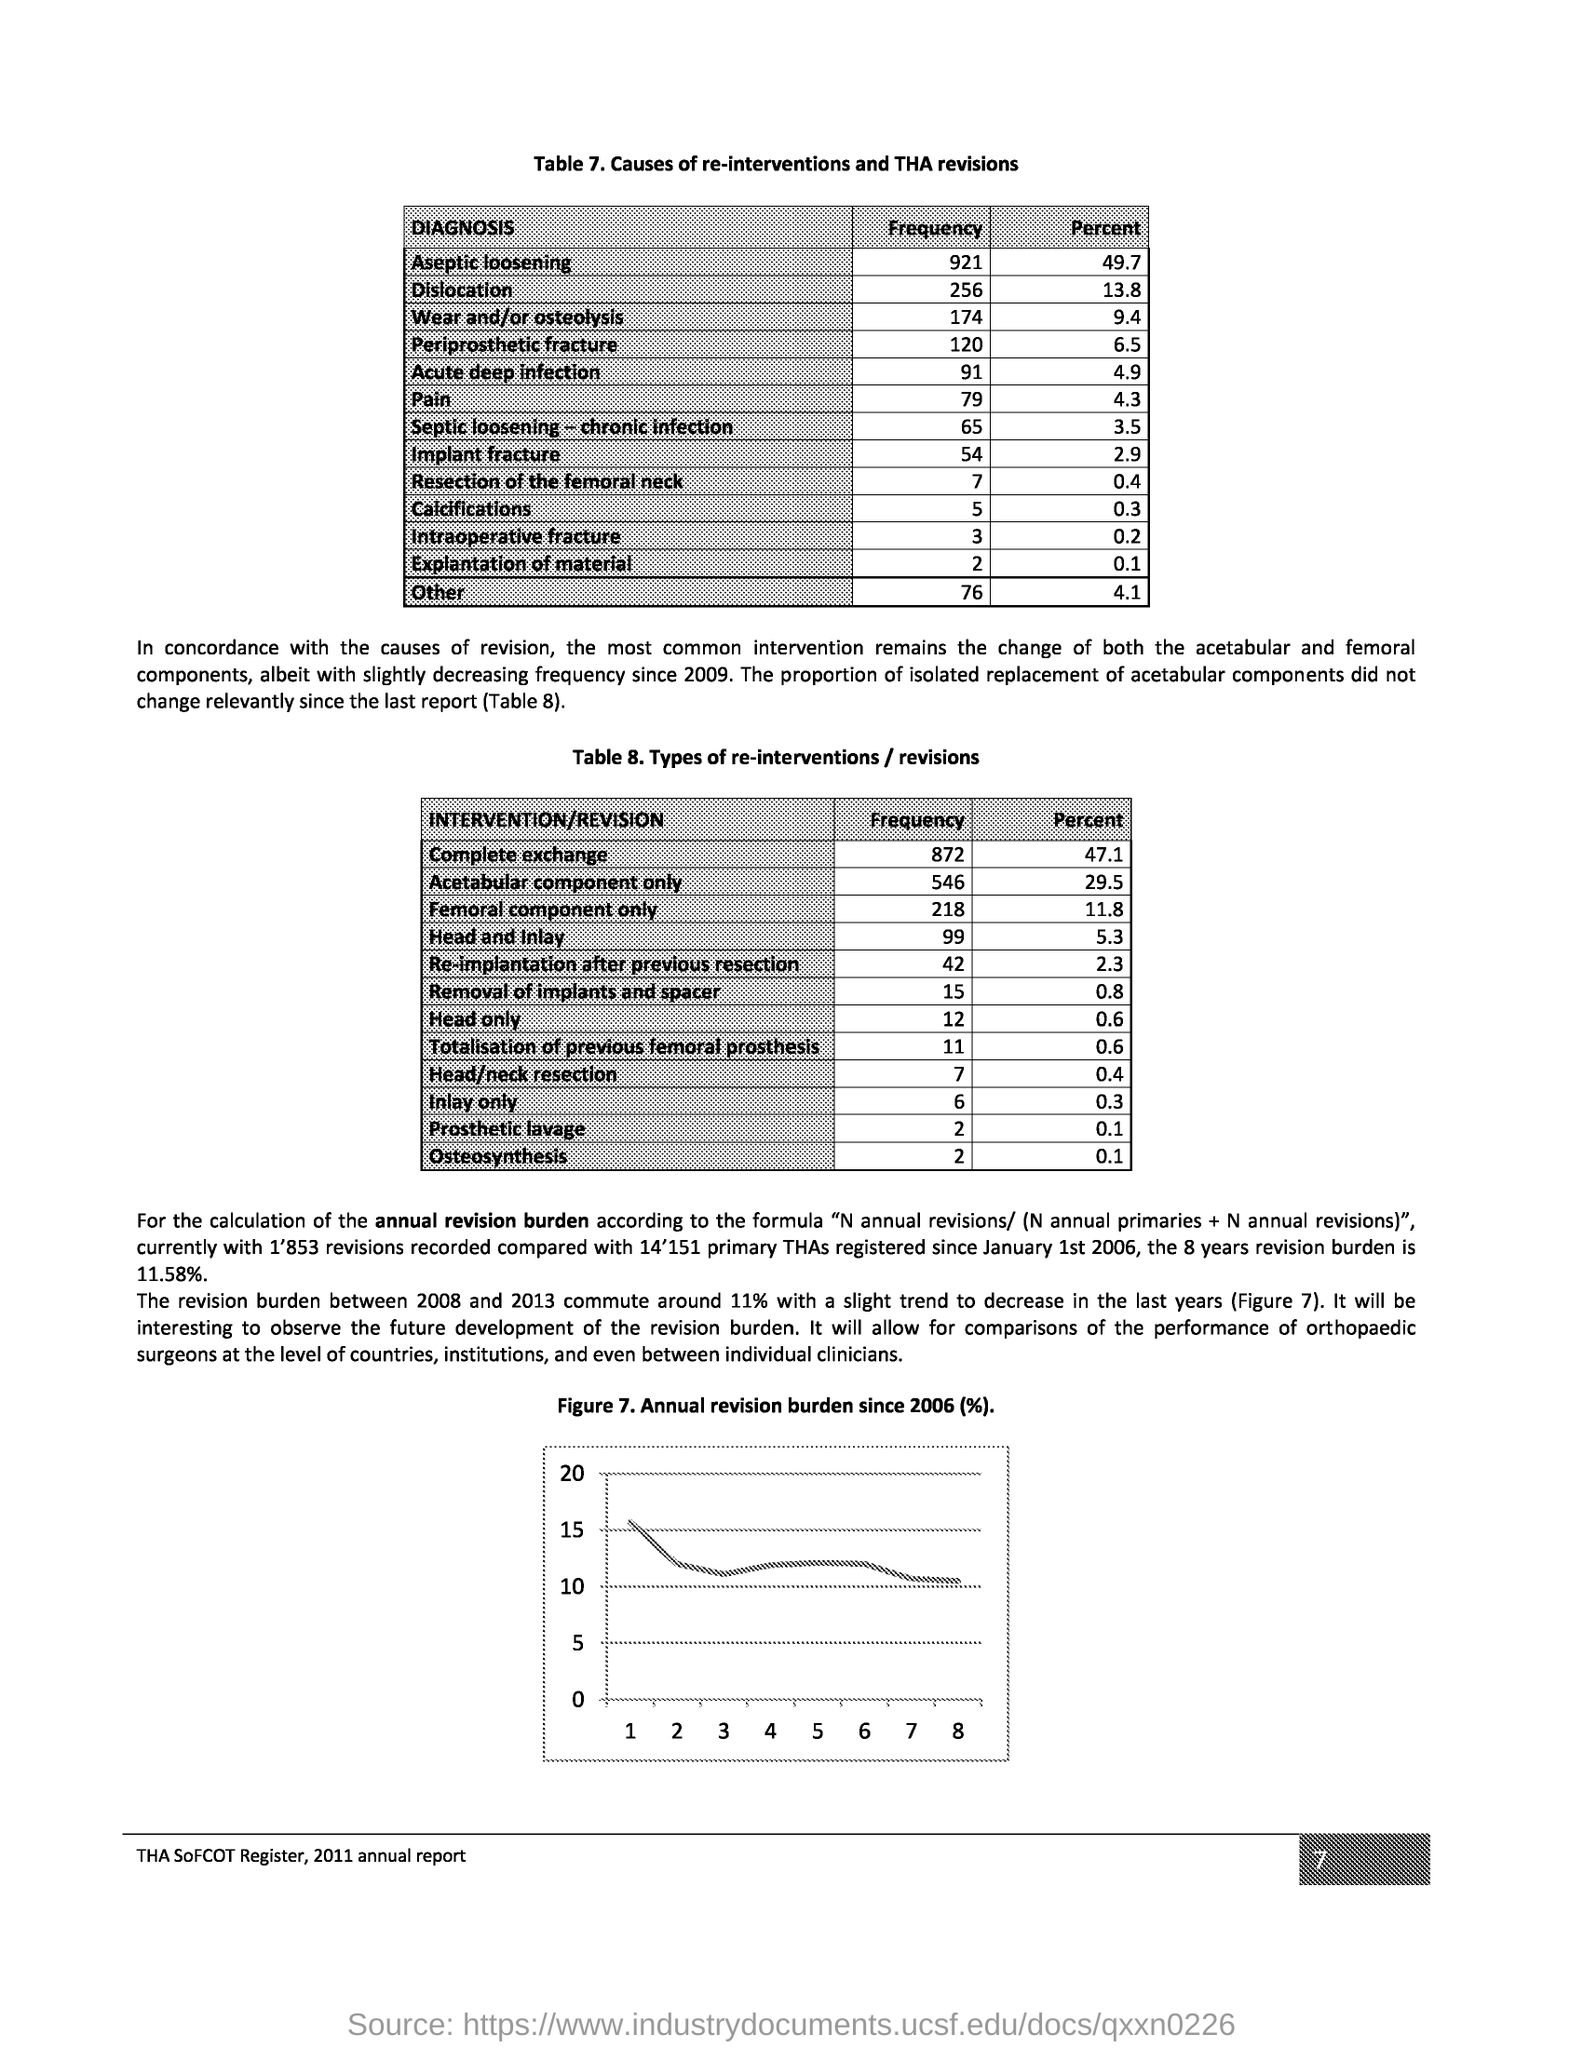What is the Page Number?
Offer a terse response. 7. 